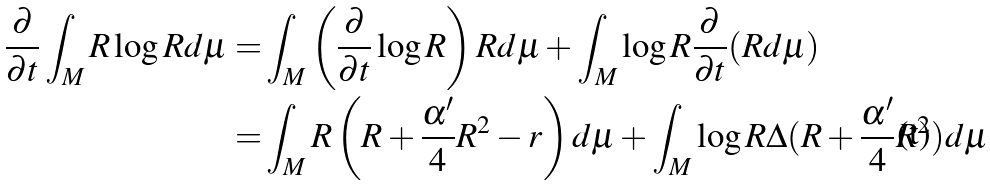<formula> <loc_0><loc_0><loc_500><loc_500>\frac { \partial } { \partial t } \int _ { M } R \log R d \mu = & \int _ { M } \left ( \frac { \partial } { \partial t } \log R \right ) R d \mu + \int _ { M } \log R \frac { \partial } { \partial t } ( R d \mu ) \\ = & \int _ { M } R \left ( R + \frac { \alpha ^ { \prime } } { 4 } R ^ { 2 } - r \right ) d \mu + \int _ { M } \log R \Delta ( R + \frac { \alpha ^ { \prime } } { 4 } R ^ { 2 } ) d \mu</formula> 